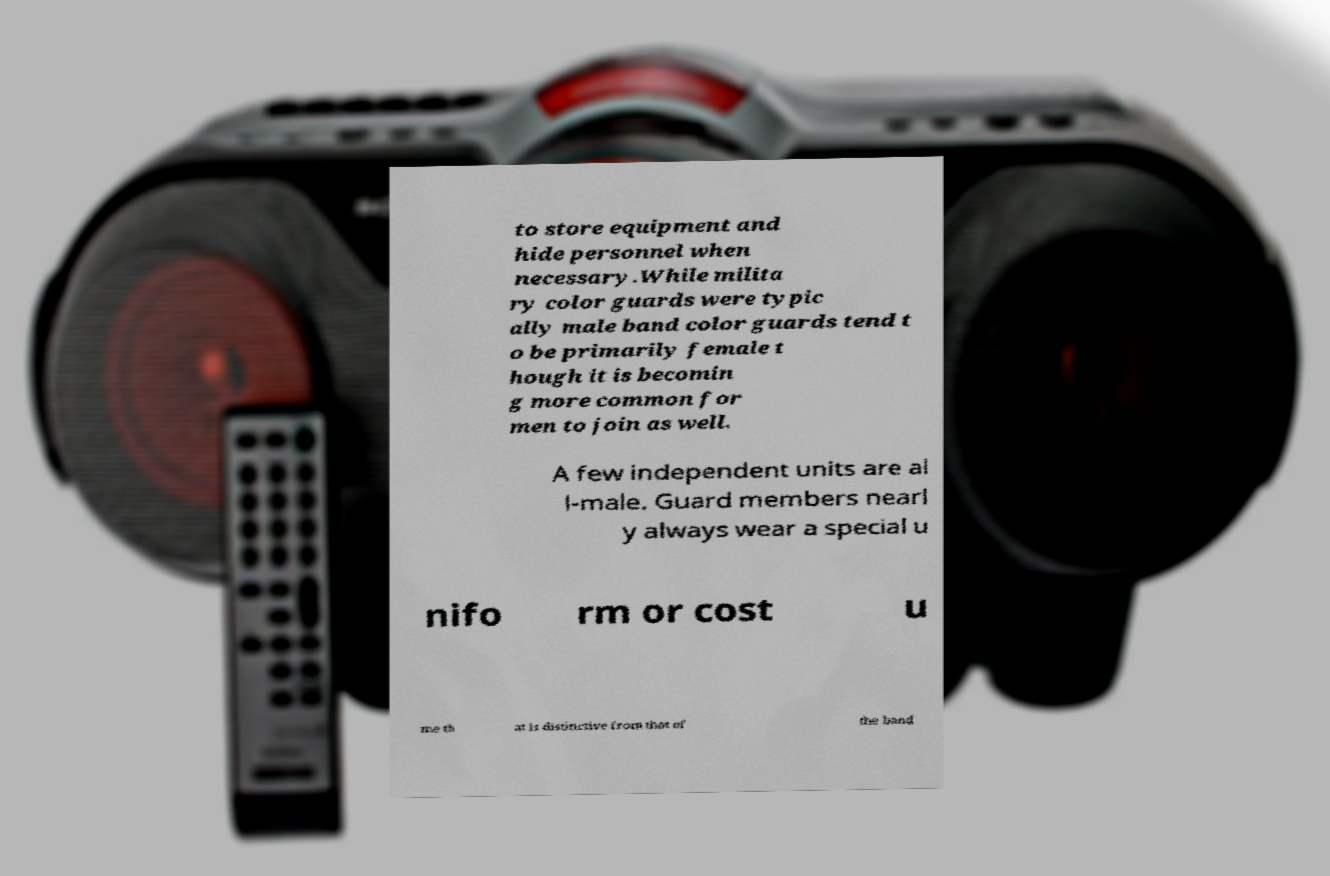Could you assist in decoding the text presented in this image and type it out clearly? to store equipment and hide personnel when necessary.While milita ry color guards were typic ally male band color guards tend t o be primarily female t hough it is becomin g more common for men to join as well. A few independent units are al l-male. Guard members nearl y always wear a special u nifo rm or cost u me th at is distinctive from that of the band 